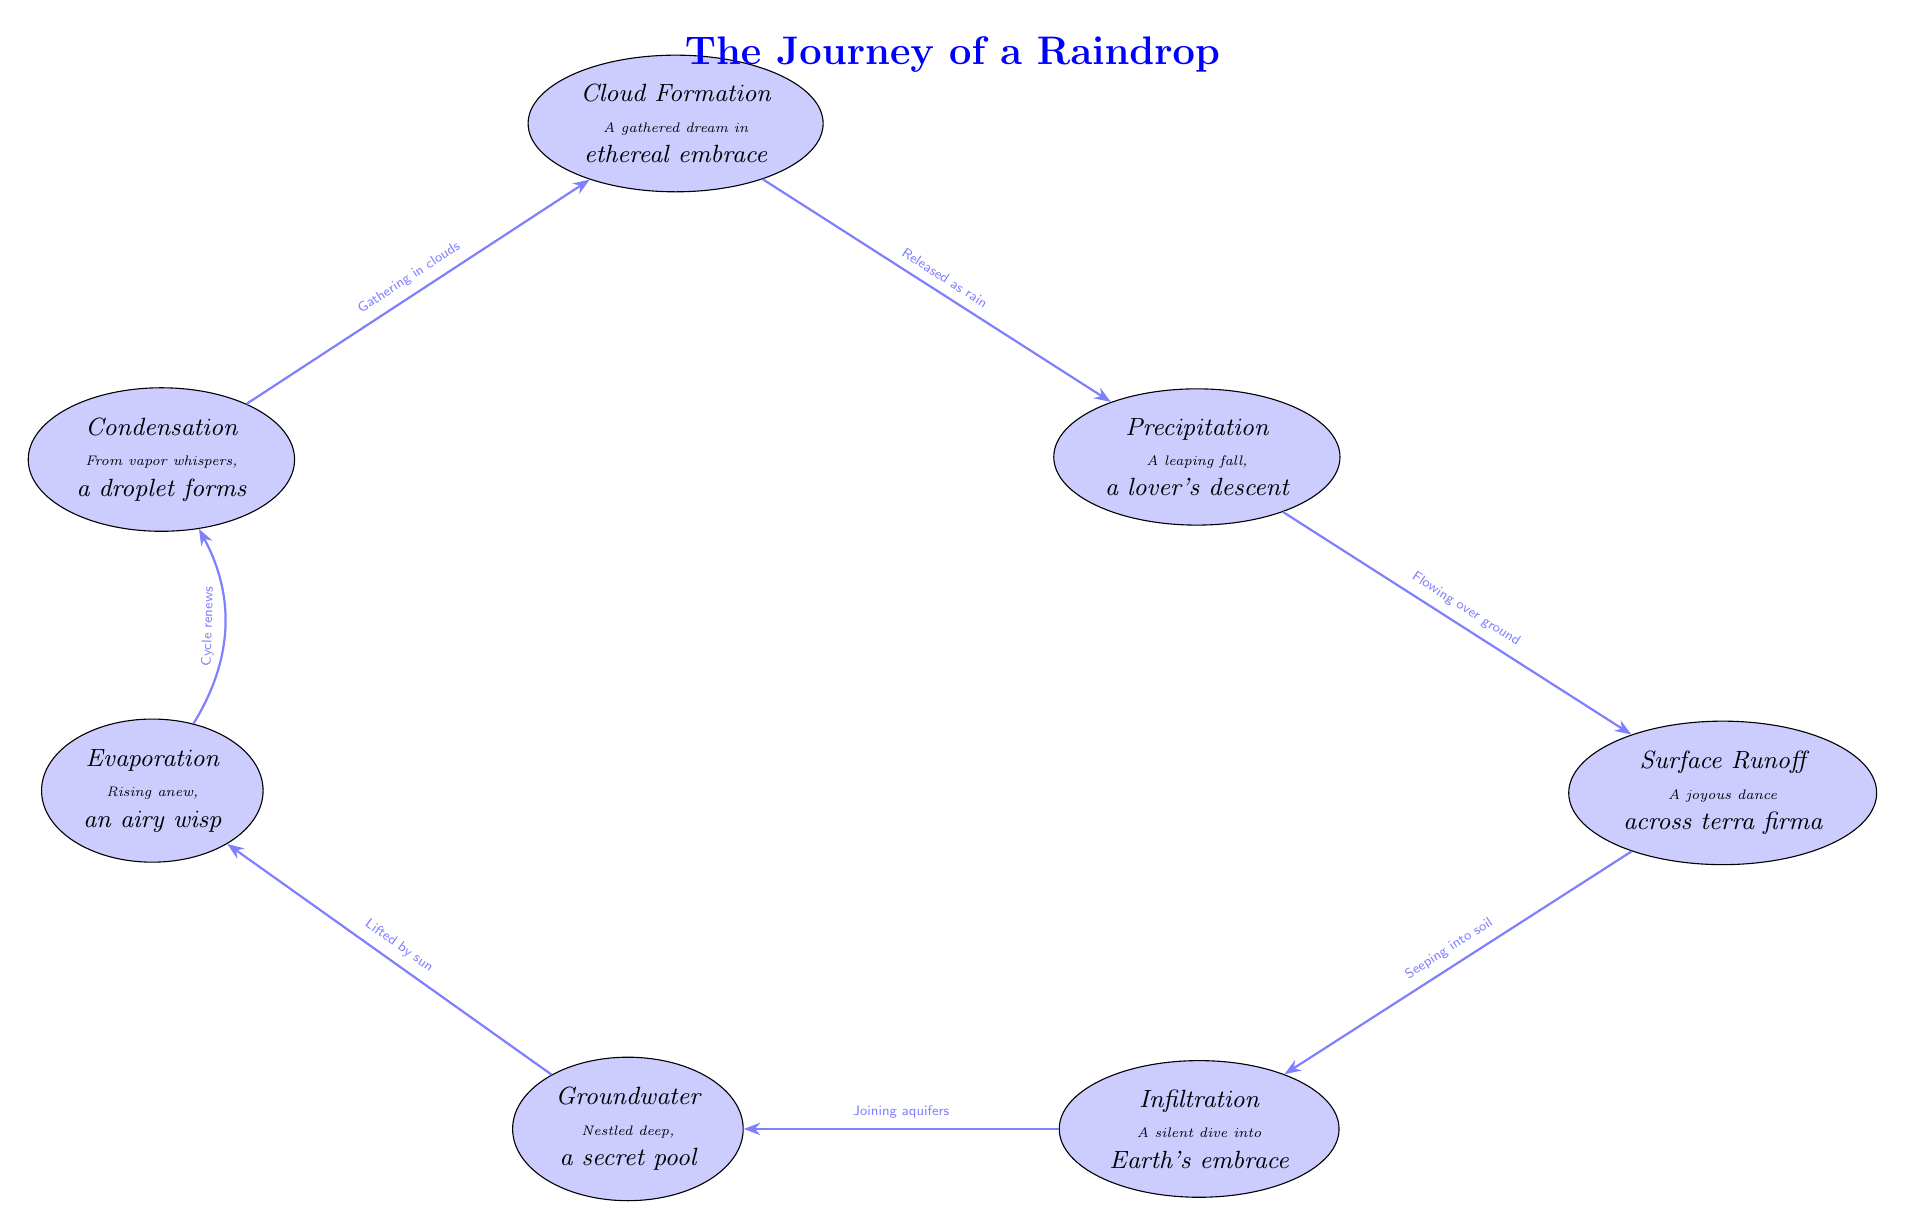What is the first phase a raindrop undergoes? The diagram lists "Condensation" as the first phase in the journey of a raindrop, as it is positioned at the top before any other phases.
Answer: Condensation How many nodes are there in the diagram? Counting each distinct phase represented by a raindrop shape shows there are six nodes, which include condensation, cloud formation, precipitation, surface runoff, infiltration, and groundwater.
Answer: 6 What is the relationship between "Cloud Formation" and "Precipitation"? The diagram indicates that "Cloud Formation" leads to "Precipitation" with an arrow labeled "Released as rain," showing a direct connection between these two phases.
Answer: Released as rain What does the raindrop do after "Infiltration"? Following "Infiltration," the diagram shows an arrow pointing to "Groundwater," indicating that after seeping into the soil, a raindrop joins the aquifers.
Answer: Groundwater What is the final stage of the raindrop's journey before the cycle renews? The last phase before the cycle restarts, as per the arrowed connection, is "Evaporation," which leads back to "Condensation," completing the cycle.
Answer: Evaporation What poetic description accompanies the "Surface Runoff" phase? The diagram provides a poetic musing alongside "Surface Runoff," reading "A joyous dance across terra firma," describing the beauty of a raindrop's movement on the ground.
Answer: A joyous dance across terra firma 